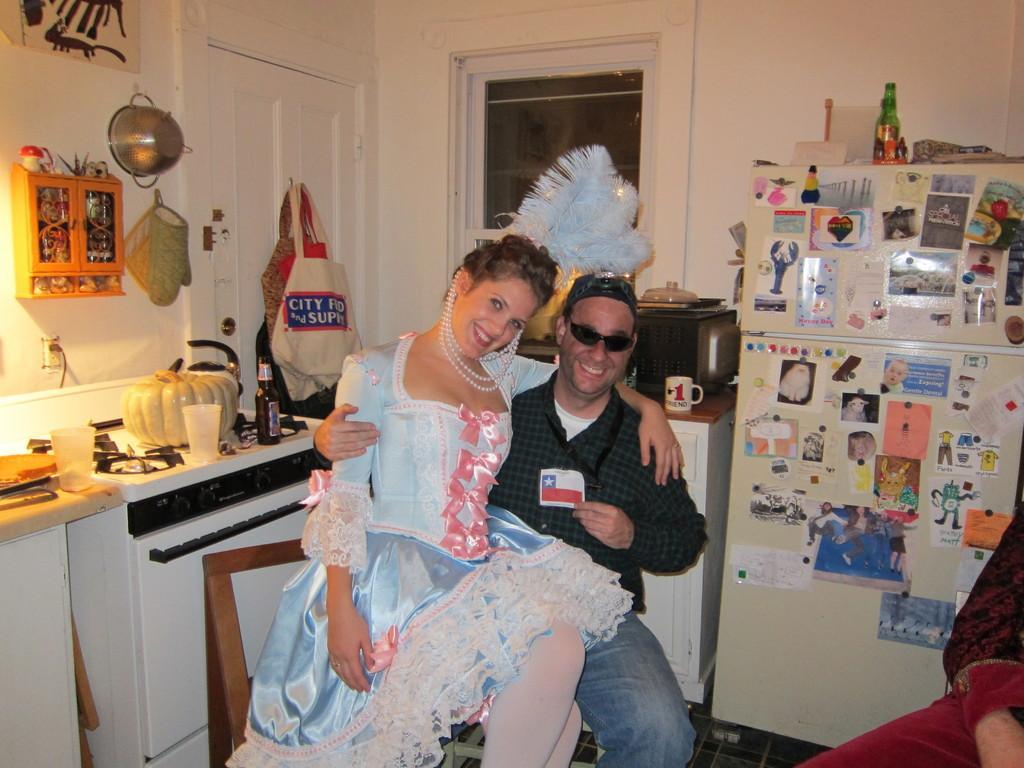Please provide a concise description of this image. In the center of the image there is a person sitting on the chair. There is a lady. In the background of the image there is wall. There is a window. There is a door. To the left side of the image there is a platform on which there are objects. To the right side of the image there is a refrigerator. There is a person. 